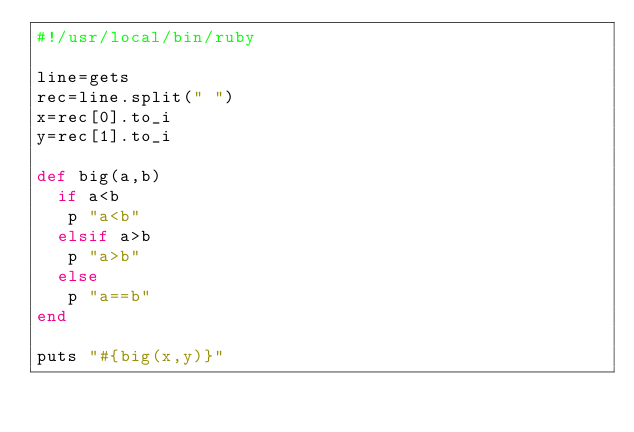<code> <loc_0><loc_0><loc_500><loc_500><_Ruby_>#!/usr/local/bin/ruby

line=gets
rec=line.split(" ") 
x=rec[0].to_i 
y=rec[1].to_i

def big(a,b)
  if a<b
   p "a<b"
  elsif a>b
   p "a>b"
  else
   p "a==b"
end

puts "#{big(x,y)}"</code> 